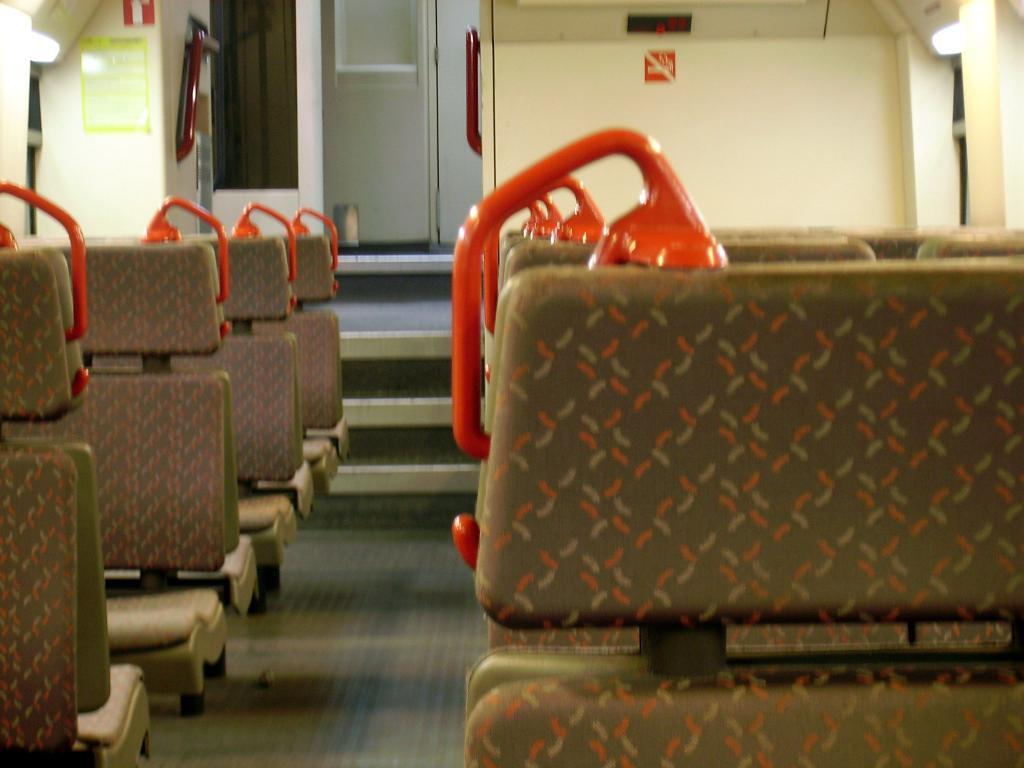What type of furniture is present in the image? There are seats in the image. What color is the wall in the image? There is a white wall in the image. What architectural feature can be seen in the image? There is a door in the image. What type of belief is depicted on the wall in the image? There is no belief depicted on the wall in the image; it is a plain white wall. What type of bushes can be seen growing near the door in the image? There are no bushes present in the image; only the seats, white wall, and door are visible. 